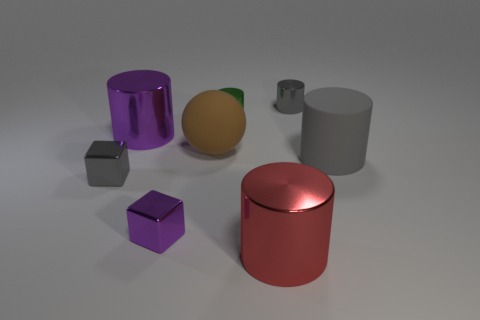Subtract all purple metal cylinders. How many cylinders are left? 4 Subtract all green cylinders. How many cylinders are left? 4 Subtract all cyan cylinders. Subtract all green cubes. How many cylinders are left? 5 Add 1 small gray metallic cylinders. How many objects exist? 9 Subtract all balls. How many objects are left? 7 Subtract 0 blue balls. How many objects are left? 8 Subtract all green metal cylinders. Subtract all tiny green things. How many objects are left? 6 Add 5 purple metallic cylinders. How many purple metallic cylinders are left? 6 Add 7 big blue rubber cubes. How many big blue rubber cubes exist? 7 